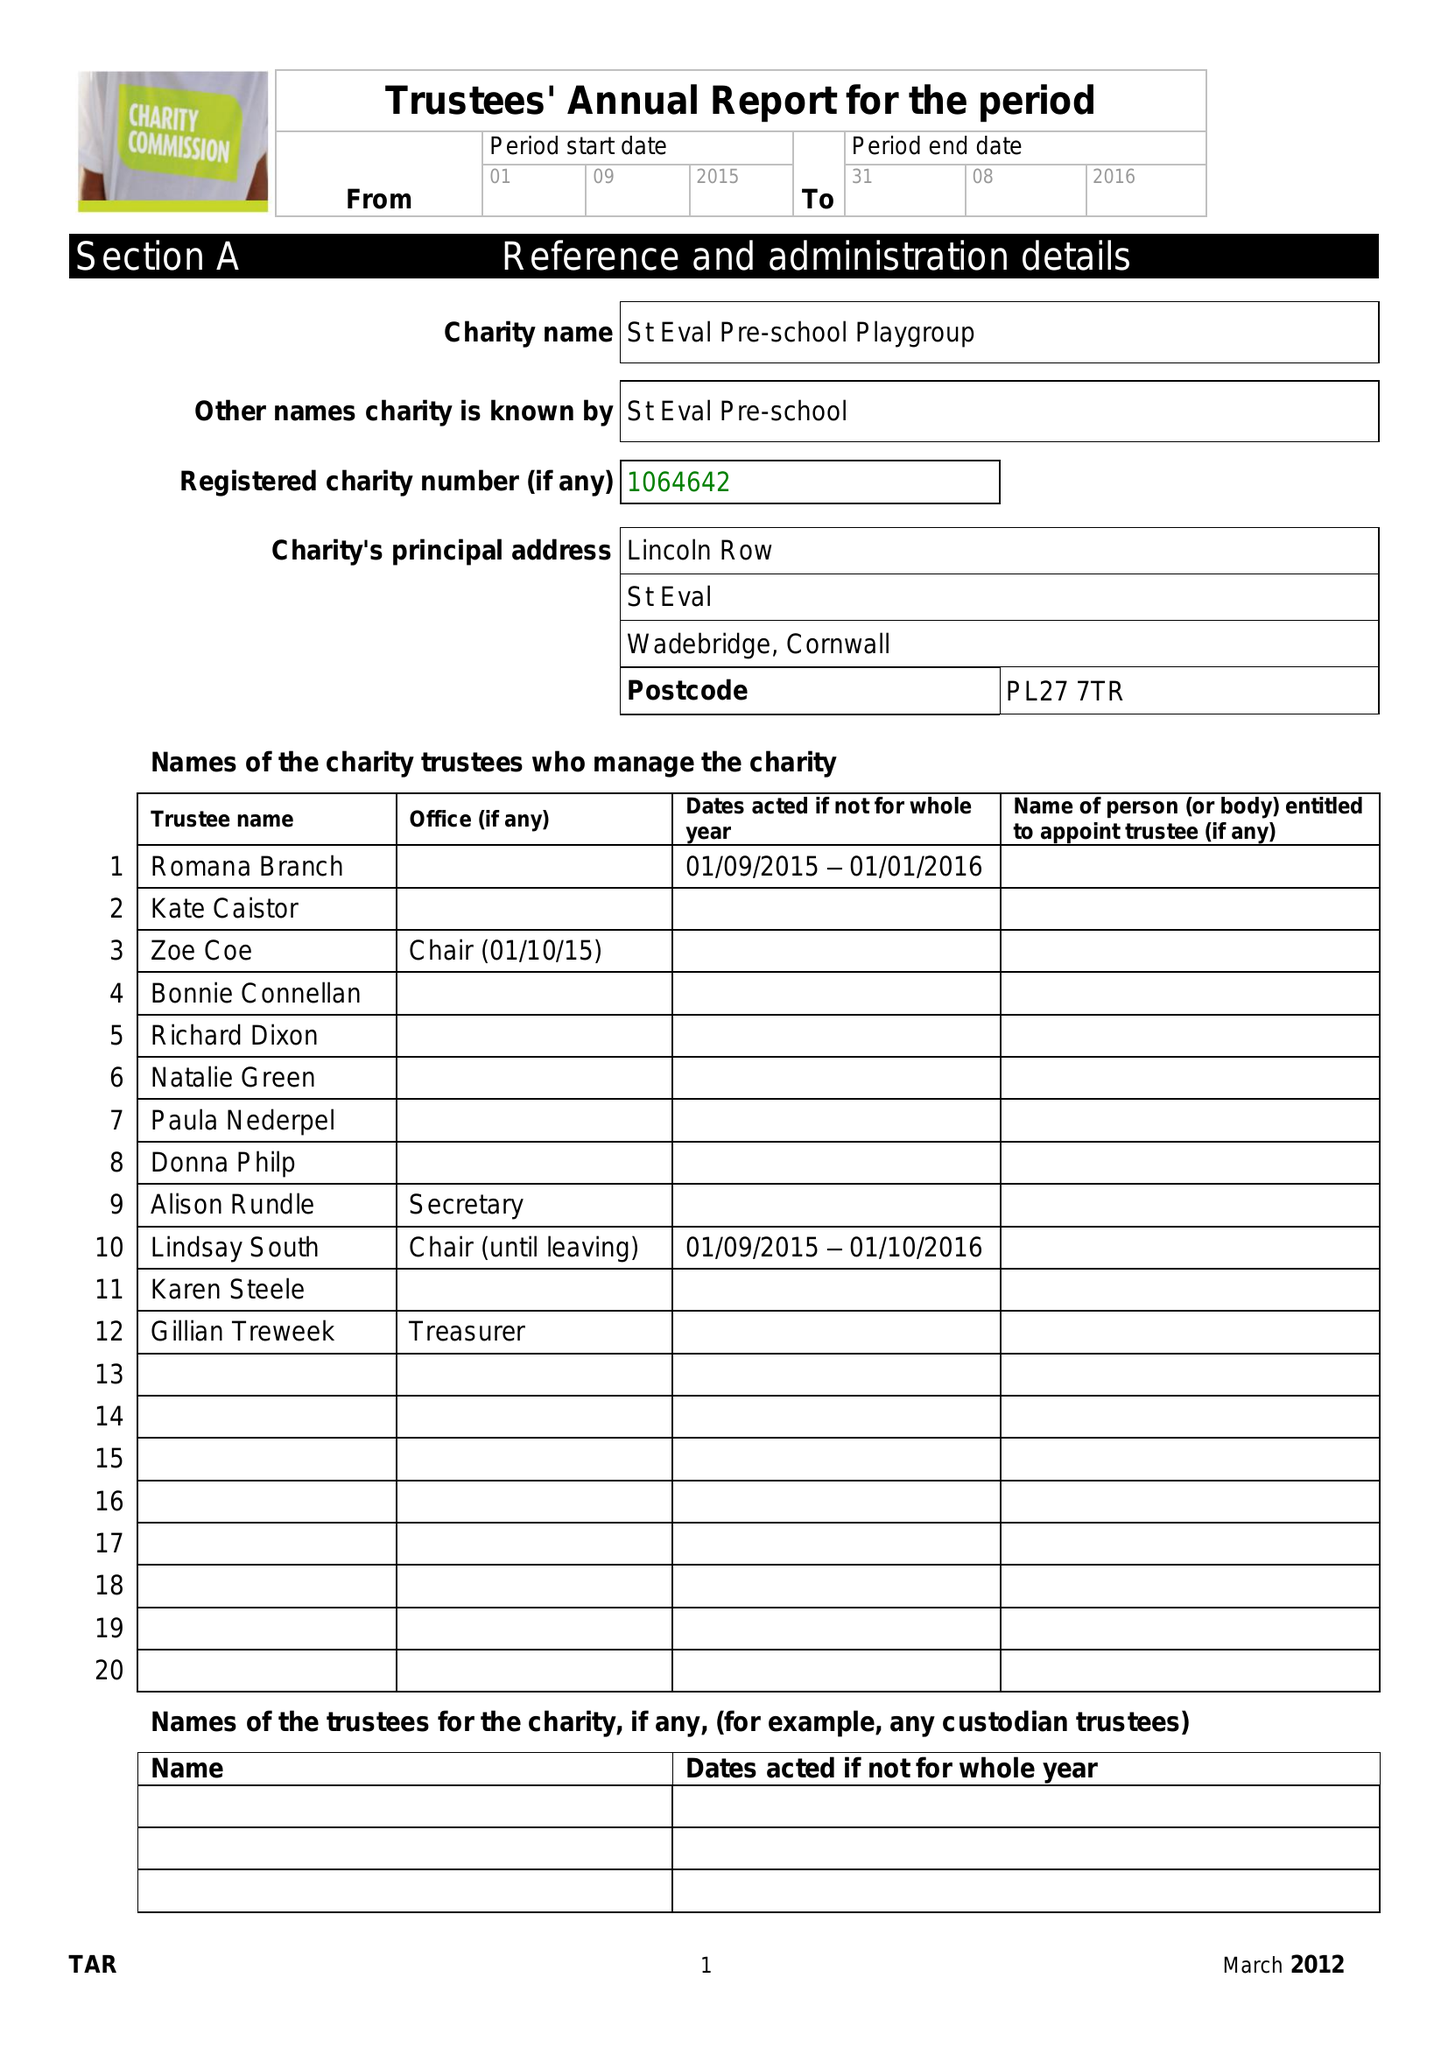What is the value for the address__street_line?
Answer the question using a single word or phrase. LINCOLN ROW 